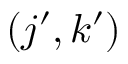Convert formula to latex. <formula><loc_0><loc_0><loc_500><loc_500>( j ^ { \prime } , k ^ { \prime } )</formula> 